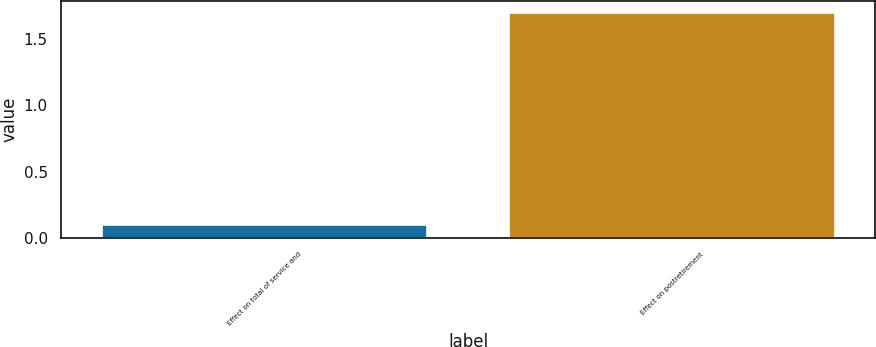Convert chart. <chart><loc_0><loc_0><loc_500><loc_500><bar_chart><fcel>Effect on total of service and<fcel>Effect on postretirement<nl><fcel>0.1<fcel>1.7<nl></chart> 